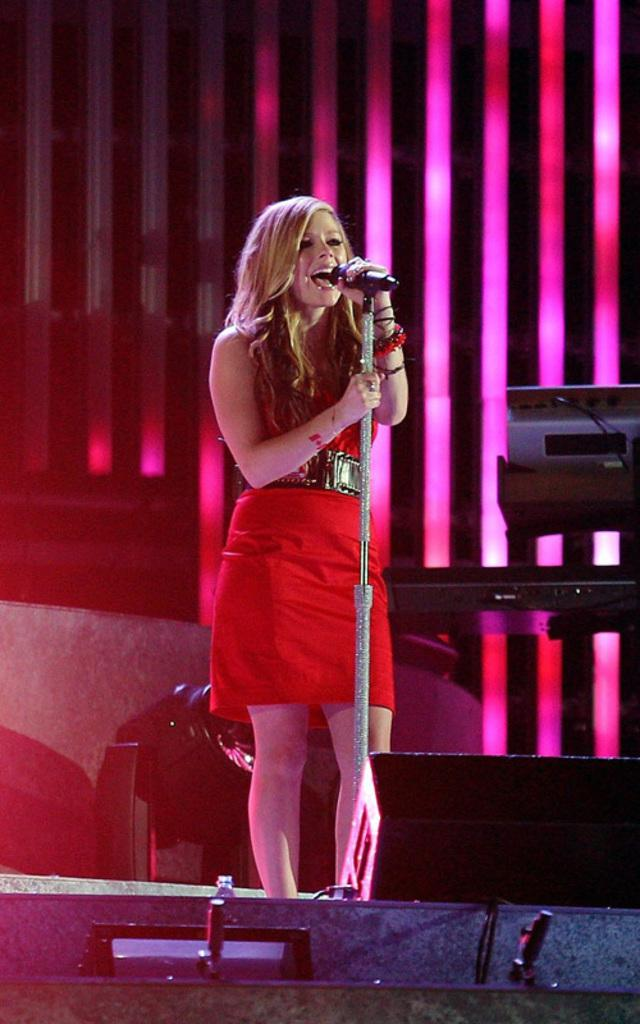Who is the main subject in the image? There is a woman in the image. Where is the woman located? The woman is standing on a stage. What is the woman holding in the image? The woman is holding a microphone with a stand. What can be seen in the background of the image? There are lights visible in the image. What musical instrument is present in the image? There is a piano in the image. What architectural feature is visible in the image? There is a wall visible in the image. Can you see any fields or trails in the image? No, there are no fields or trails visible in the image. 